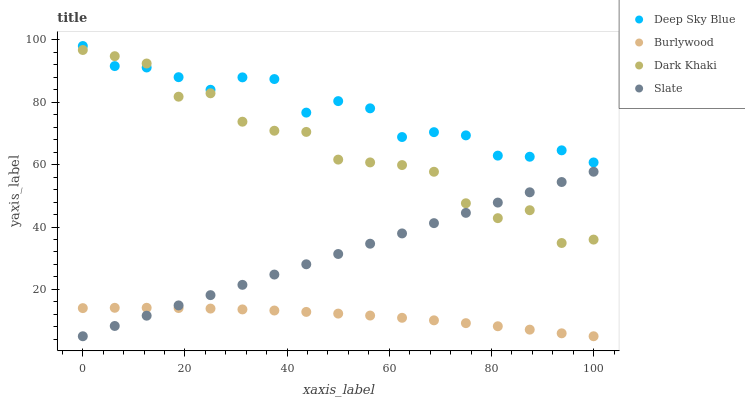Does Burlywood have the minimum area under the curve?
Answer yes or no. Yes. Does Deep Sky Blue have the maximum area under the curve?
Answer yes or no. Yes. Does Dark Khaki have the minimum area under the curve?
Answer yes or no. No. Does Dark Khaki have the maximum area under the curve?
Answer yes or no. No. Is Slate the smoothest?
Answer yes or no. Yes. Is Dark Khaki the roughest?
Answer yes or no. Yes. Is Dark Khaki the smoothest?
Answer yes or no. No. Is Slate the roughest?
Answer yes or no. No. Does Burlywood have the lowest value?
Answer yes or no. Yes. Does Dark Khaki have the lowest value?
Answer yes or no. No. Does Deep Sky Blue have the highest value?
Answer yes or no. Yes. Does Dark Khaki have the highest value?
Answer yes or no. No. Is Burlywood less than Dark Khaki?
Answer yes or no. Yes. Is Deep Sky Blue greater than Slate?
Answer yes or no. Yes. Does Slate intersect Dark Khaki?
Answer yes or no. Yes. Is Slate less than Dark Khaki?
Answer yes or no. No. Is Slate greater than Dark Khaki?
Answer yes or no. No. Does Burlywood intersect Dark Khaki?
Answer yes or no. No. 